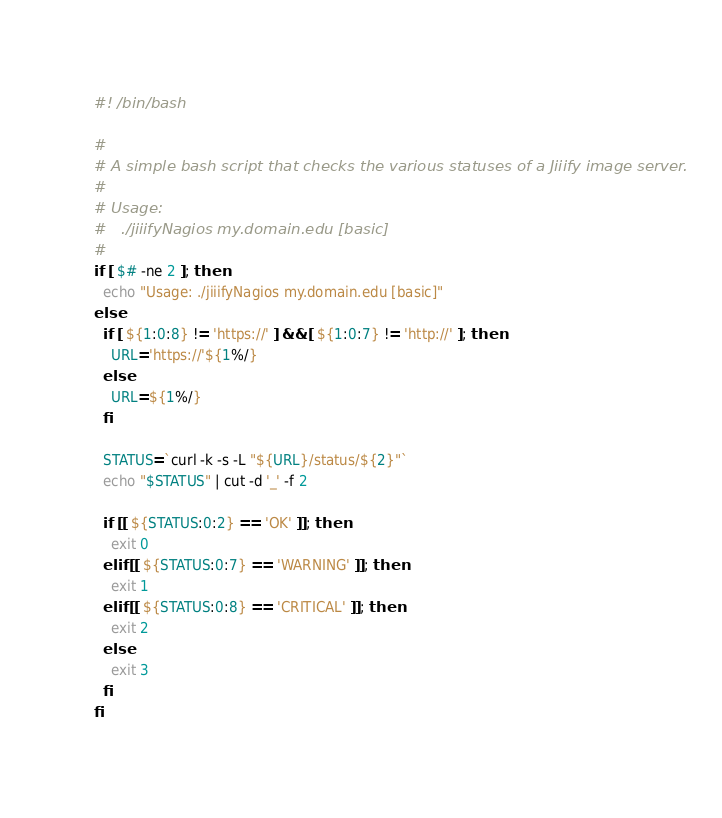Convert code to text. <code><loc_0><loc_0><loc_500><loc_500><_Bash_>#! /bin/bash

#
# A simple bash script that checks the various statuses of a Jiiify image server.
#
# Usage:
#   ./jiiifyNagios my.domain.edu [basic]
#
if [ $# -ne 2 ]; then
  echo "Usage: ./jiiifyNagios my.domain.edu [basic]"
else
  if [ ${1:0:8} != 'https://' ] && [ ${1:0:7} != 'http://' ]; then
    URL='https://'${1%/}
  else
    URL=${1%/}
  fi

  STATUS=`curl -k -s -L "${URL}/status/${2}"`
  echo "$STATUS" | cut -d '_' -f 2

  if [[ ${STATUS:0:2} == 'OK' ]]; then
    exit 0
  elif [[ ${STATUS:0:7} == 'WARNING' ]]; then
    exit 1
  elif [[ ${STATUS:0:8} == 'CRITICAL' ]]; then
    exit 2
  else
    exit 3
  fi
fi
</code> 